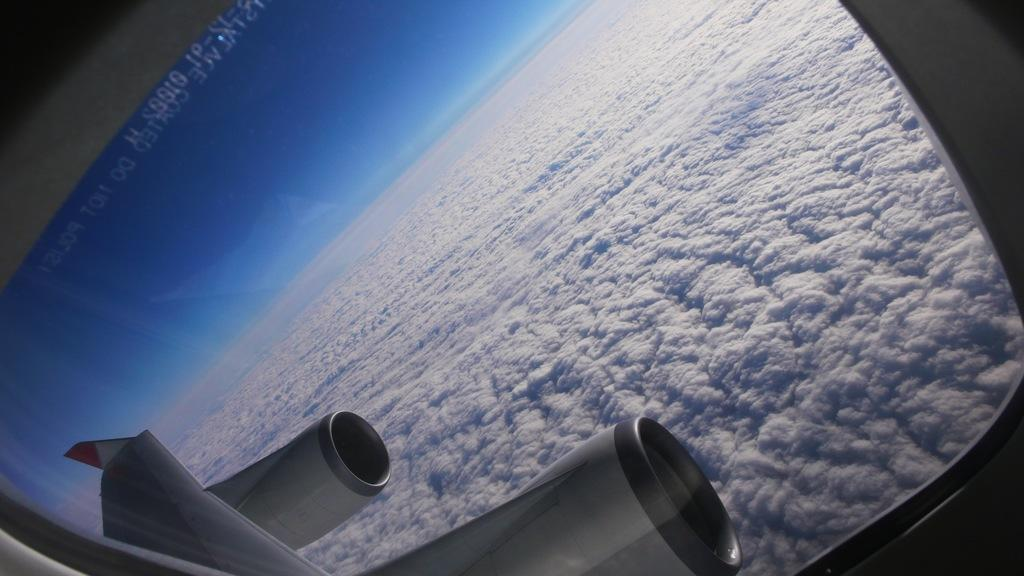What is the vantage point of the image? The image is taken from an airplane window seat. What can be seen in the background of the image? The airplane wing and propeller shafts are visible in the background. What is the condition of the sky in the image? The sky is blue and there are clouds present. What type of club can be seen in the image? There is no club present in the image; it is taken from an airplane window seat and features the airplane wing, propeller shafts, and a blue sky with clouds. Is the image taken in space? No, the image is not taken in space; it is taken from an airplane window seat, as indicated by the presence of the airplane wing and propeller shafts. 